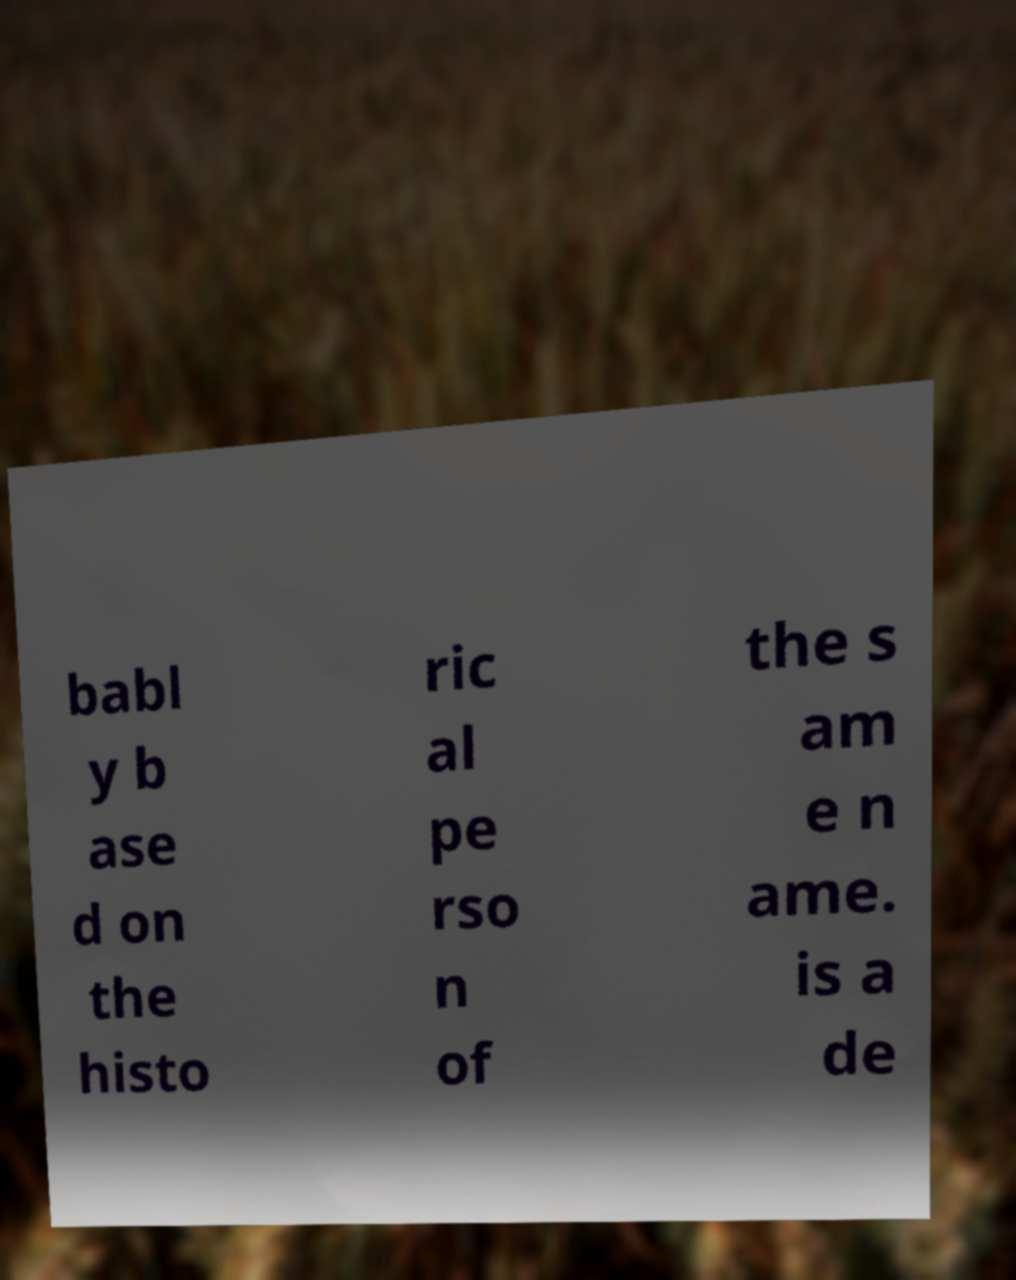Please identify and transcribe the text found in this image. babl y b ase d on the histo ric al pe rso n of the s am e n ame. is a de 